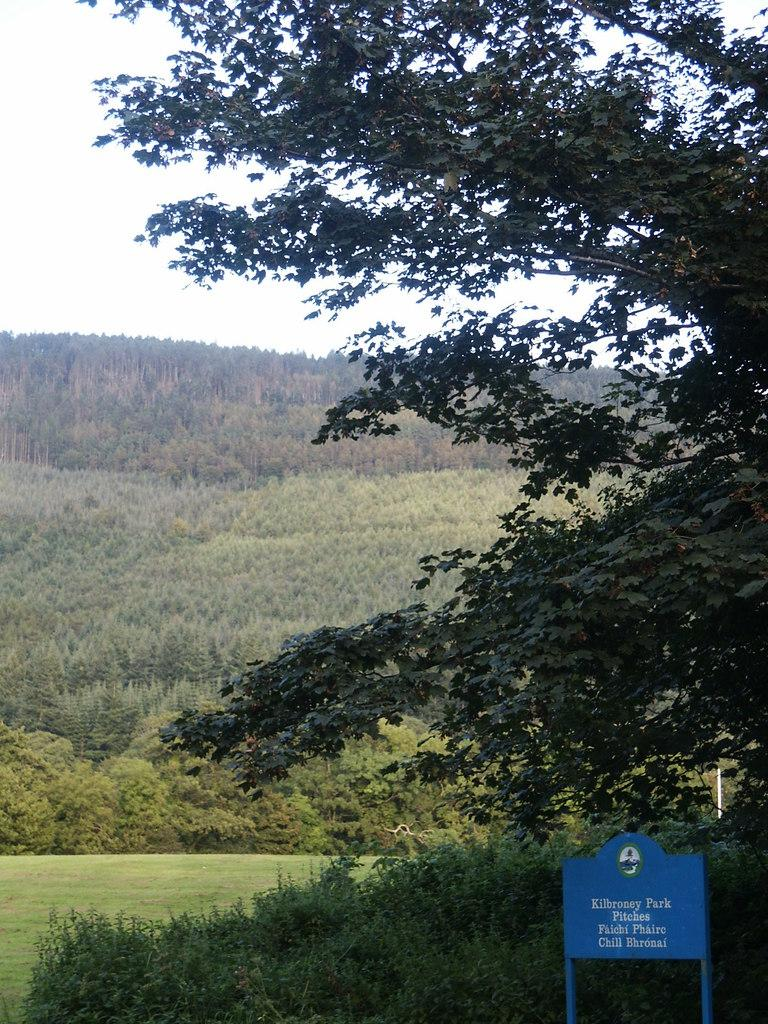What is written on the board in the image? The facts do not specify the text on the board, so we cannot answer this question definitively. What type of plants are visible in the image? The facts do not specify the type of plants, so we cannot answer this question definitively. What is the primary feature visible in the background of the image? There is a mountain visible in the background of the image. What type of vegetation is present in the image? There are plants and trees visible in the image. How many pets are visible in the image? There are no pets visible in the image. What type of yarn is being used by the women in the image? There are no women or yarn present in the image. 